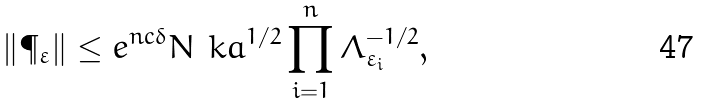Convert formula to latex. <formula><loc_0><loc_0><loc_500><loc_500>\| \P _ { \varepsilon } \| \leq e ^ { n c \delta } N _ { \ } k a ^ { 1 / 2 } \prod _ { i = 1 } ^ { n } \Lambda ^ { - 1 / 2 } _ { \varepsilon _ { i } } ,</formula> 